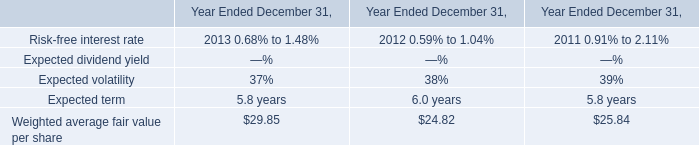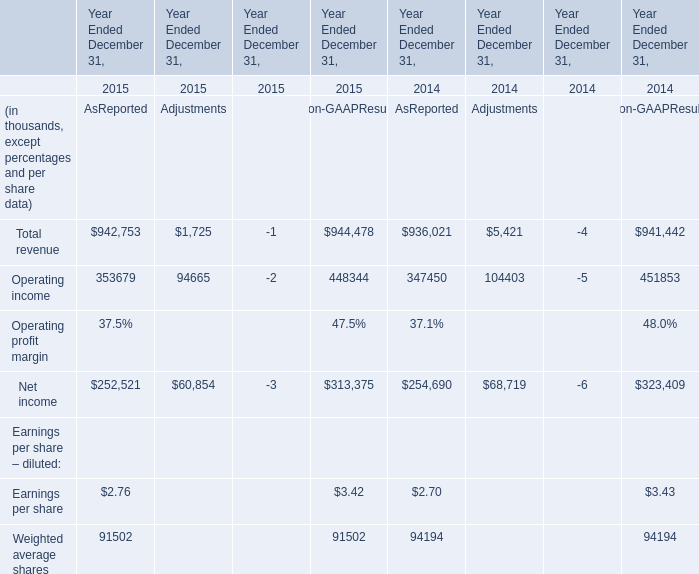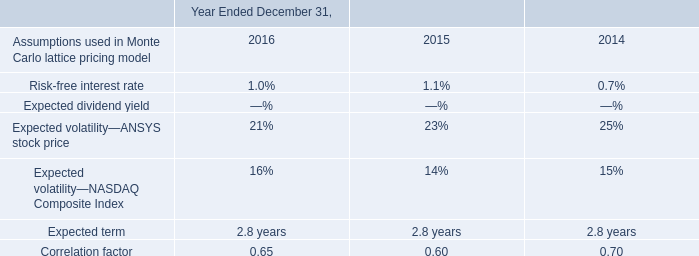What's the sum of the Operating income for Adjustments in the years where Total revenue positive for Adjustments? (in thousand) 
Computations: (94665 + 104403)
Answer: 199068.0. what was the average total compensation expense associated with the awards from 2014 to 2016 in millions 
Computations: (((1.9 + 4.0) + 3.5) / 3)
Answer: 3.13333. What's the average of Operating income and Total revenue in 2015 for Adjustments? (in thousand) 
Computations: ((1725 + 94665) / 2)
Answer: 48195.0. what was the value of the restricted stock that the company granted in 2016? 
Computations: (488622 * 88.51)
Answer: 43247933.22. 